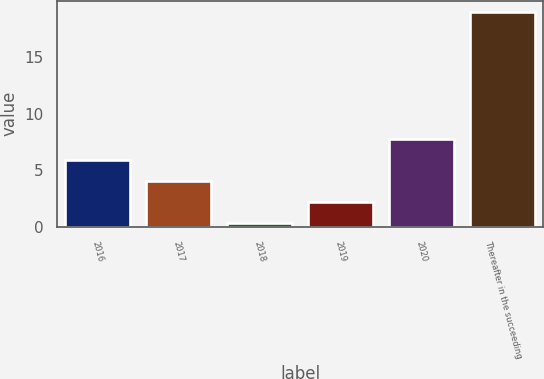Convert chart. <chart><loc_0><loc_0><loc_500><loc_500><bar_chart><fcel>2016<fcel>2017<fcel>2018<fcel>2019<fcel>2020<fcel>Thereafter in the succeeding<nl><fcel>5.91<fcel>4.04<fcel>0.3<fcel>2.17<fcel>7.78<fcel>19<nl></chart> 